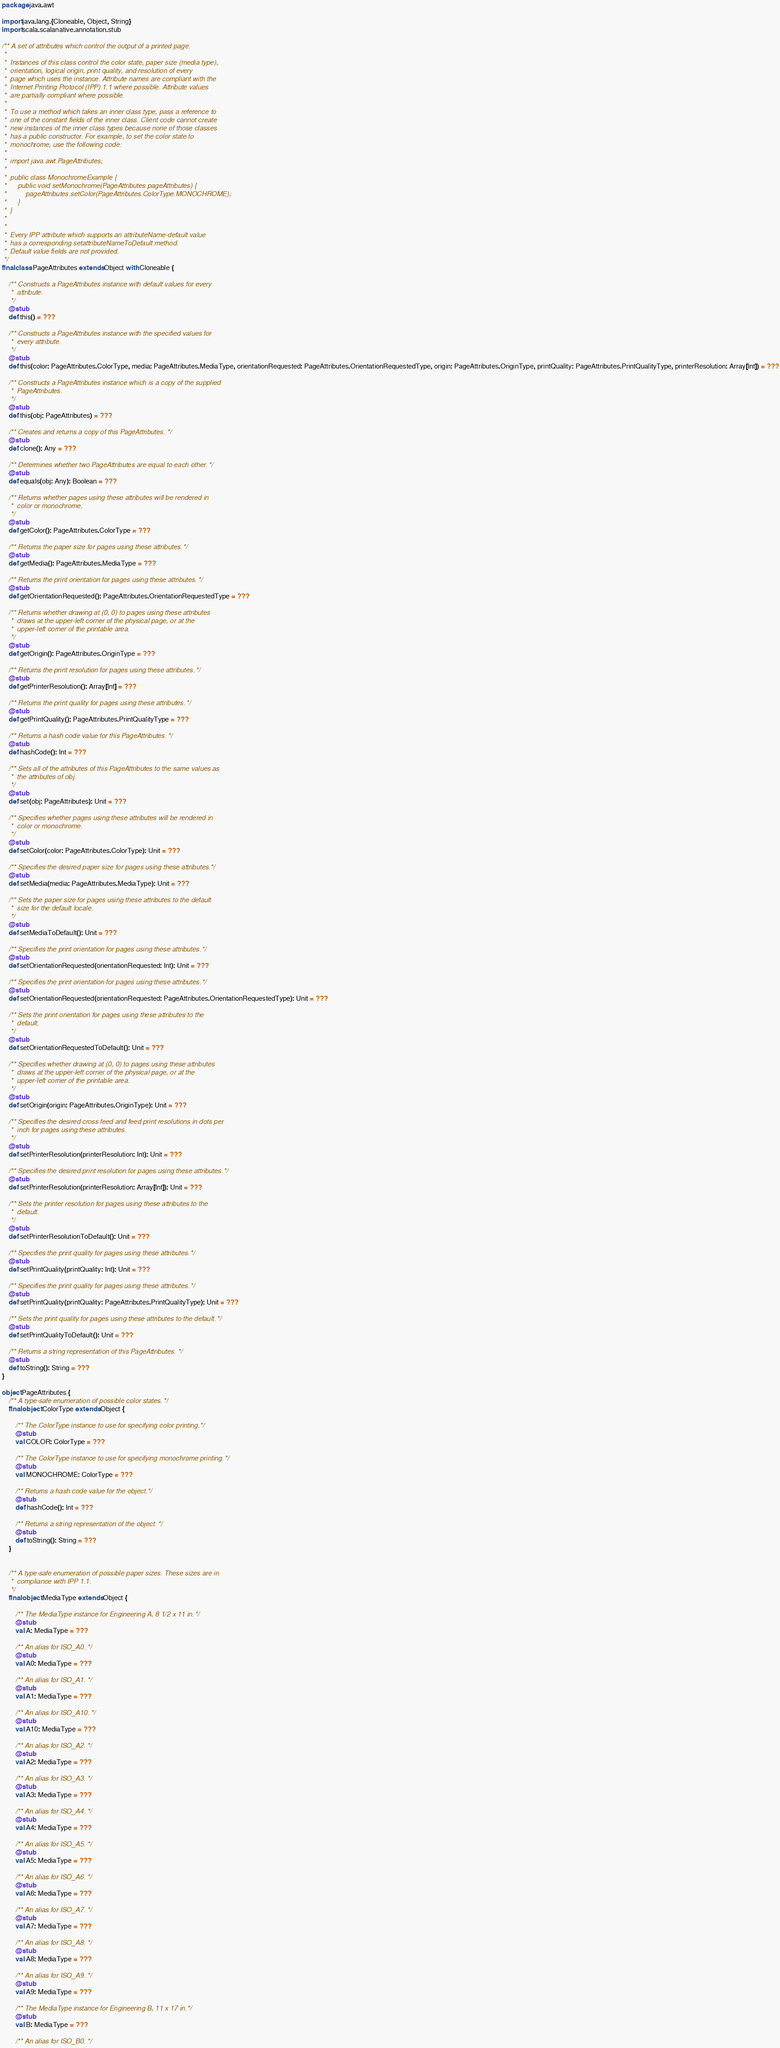<code> <loc_0><loc_0><loc_500><loc_500><_Scala_>package java.awt

import java.lang.{Cloneable, Object, String}
import scala.scalanative.annotation.stub

/** A set of attributes which control the output of a printed page.
 *  
 *  Instances of this class control the color state, paper size (media type),
 *  orientation, logical origin, print quality, and resolution of every
 *  page which uses the instance. Attribute names are compliant with the
 *  Internet Printing Protocol (IPP) 1.1 where possible. Attribute values
 *  are partially compliant where possible.
 *  
 *  To use a method which takes an inner class type, pass a reference to
 *  one of the constant fields of the inner class. Client code cannot create
 *  new instances of the inner class types because none of those classes
 *  has a public constructor. For example, to set the color state to
 *  monochrome, use the following code:
 *  
 *  import java.awt.PageAttributes;
 * 
 *  public class MonochromeExample {
 *      public void setMonochrome(PageAttributes pageAttributes) {
 *          pageAttributes.setColor(PageAttributes.ColorType.MONOCHROME);
 *      }
 *  }
 *  
 *  
 *  Every IPP attribute which supports an attributeName-default value
 *  has a corresponding setattributeNameToDefault method.
 *  Default value fields are not provided.
 */
final class PageAttributes extends Object with Cloneable {

    /** Constructs a PageAttributes instance with default values for every
     *  attribute.
     */
    @stub
    def this() = ???

    /** Constructs a PageAttributes instance with the specified values for
     *  every attribute.
     */
    @stub
    def this(color: PageAttributes.ColorType, media: PageAttributes.MediaType, orientationRequested: PageAttributes.OrientationRequestedType, origin: PageAttributes.OriginType, printQuality: PageAttributes.PrintQualityType, printerResolution: Array[Int]) = ???

    /** Constructs a PageAttributes instance which is a copy of the supplied
     *  PageAttributes.
     */
    @stub
    def this(obj: PageAttributes) = ???

    /** Creates and returns a copy of this PageAttributes. */
    @stub
    def clone(): Any = ???

    /** Determines whether two PageAttributes are equal to each other. */
    @stub
    def equals(obj: Any): Boolean = ???

    /** Returns whether pages using these attributes will be rendered in
     *  color or monochrome.
     */
    @stub
    def getColor(): PageAttributes.ColorType = ???

    /** Returns the paper size for pages using these attributes. */
    @stub
    def getMedia(): PageAttributes.MediaType = ???

    /** Returns the print orientation for pages using these attributes. */
    @stub
    def getOrientationRequested(): PageAttributes.OrientationRequestedType = ???

    /** Returns whether drawing at (0, 0) to pages using these attributes
     *  draws at the upper-left corner of the physical page, or at the
     *  upper-left corner of the printable area.
     */
    @stub
    def getOrigin(): PageAttributes.OriginType = ???

    /** Returns the print resolution for pages using these attributes. */
    @stub
    def getPrinterResolution(): Array[Int] = ???

    /** Returns the print quality for pages using these attributes. */
    @stub
    def getPrintQuality(): PageAttributes.PrintQualityType = ???

    /** Returns a hash code value for this PageAttributes. */
    @stub
    def hashCode(): Int = ???

    /** Sets all of the attributes of this PageAttributes to the same values as
     *  the attributes of obj.
     */
    @stub
    def set(obj: PageAttributes): Unit = ???

    /** Specifies whether pages using these attributes will be rendered in
     *  color or monochrome.
     */
    @stub
    def setColor(color: PageAttributes.ColorType): Unit = ???

    /** Specifies the desired paper size for pages using these attributes. */
    @stub
    def setMedia(media: PageAttributes.MediaType): Unit = ???

    /** Sets the paper size for pages using these attributes to the default
     *  size for the default locale.
     */
    @stub
    def setMediaToDefault(): Unit = ???

    /** Specifies the print orientation for pages using these attributes. */
    @stub
    def setOrientationRequested(orientationRequested: Int): Unit = ???

    /** Specifies the print orientation for pages using these attributes. */
    @stub
    def setOrientationRequested(orientationRequested: PageAttributes.OrientationRequestedType): Unit = ???

    /** Sets the print orientation for pages using these attributes to the
     *  default.
     */
    @stub
    def setOrientationRequestedToDefault(): Unit = ???

    /** Specifies whether drawing at (0, 0) to pages using these attributes
     *  draws at the upper-left corner of the physical page, or at the
     *  upper-left corner of the printable area.
     */
    @stub
    def setOrigin(origin: PageAttributes.OriginType): Unit = ???

    /** Specifies the desired cross feed and feed print resolutions in dots per
     *  inch for pages using these attributes.
     */
    @stub
    def setPrinterResolution(printerResolution: Int): Unit = ???

    /** Specifies the desired print resolution for pages using these attributes. */
    @stub
    def setPrinterResolution(printerResolution: Array[Int]): Unit = ???

    /** Sets the printer resolution for pages using these attributes to the
     *  default.
     */
    @stub
    def setPrinterResolutionToDefault(): Unit = ???

    /** Specifies the print quality for pages using these attributes. */
    @stub
    def setPrintQuality(printQuality: Int): Unit = ???

    /** Specifies the print quality for pages using these attributes. */
    @stub
    def setPrintQuality(printQuality: PageAttributes.PrintQualityType): Unit = ???

    /** Sets the print quality for pages using these attributes to the default. */
    @stub
    def setPrintQualityToDefault(): Unit = ???

    /** Returns a string representation of this PageAttributes. */
    @stub
    def toString(): String = ???
}

object PageAttributes {
    /** A type-safe enumeration of possible color states. */
    final object ColorType extends Object {

        /** The ColorType instance to use for specifying color printing. */
        @stub
        val COLOR: ColorType = ???

        /** The ColorType instance to use for specifying monochrome printing. */
        @stub
        val MONOCHROME: ColorType = ???

        /** Returns a hash code value for the object. */
        @stub
        def hashCode(): Int = ???

        /** Returns a string representation of the object. */
        @stub
        def toString(): String = ???
    }


    /** A type-safe enumeration of possible paper sizes. These sizes are in
     *  compliance with IPP 1.1.
     */
    final object MediaType extends Object {

        /** The MediaType instance for Engineering A, 8 1/2 x 11 in. */
        @stub
        val A: MediaType = ???

        /** An alias for ISO_A0. */
        @stub
        val A0: MediaType = ???

        /** An alias for ISO_A1. */
        @stub
        val A1: MediaType = ???

        /** An alias for ISO_A10. */
        @stub
        val A10: MediaType = ???

        /** An alias for ISO_A2. */
        @stub
        val A2: MediaType = ???

        /** An alias for ISO_A3. */
        @stub
        val A3: MediaType = ???

        /** An alias for ISO_A4. */
        @stub
        val A4: MediaType = ???

        /** An alias for ISO_A5. */
        @stub
        val A5: MediaType = ???

        /** An alias for ISO_A6. */
        @stub
        val A6: MediaType = ???

        /** An alias for ISO_A7. */
        @stub
        val A7: MediaType = ???

        /** An alias for ISO_A8. */
        @stub
        val A8: MediaType = ???

        /** An alias for ISO_A9. */
        @stub
        val A9: MediaType = ???

        /** The MediaType instance for Engineering B, 11 x 17 in. */
        @stub
        val B: MediaType = ???

        /** An alias for ISO_B0. */</code> 